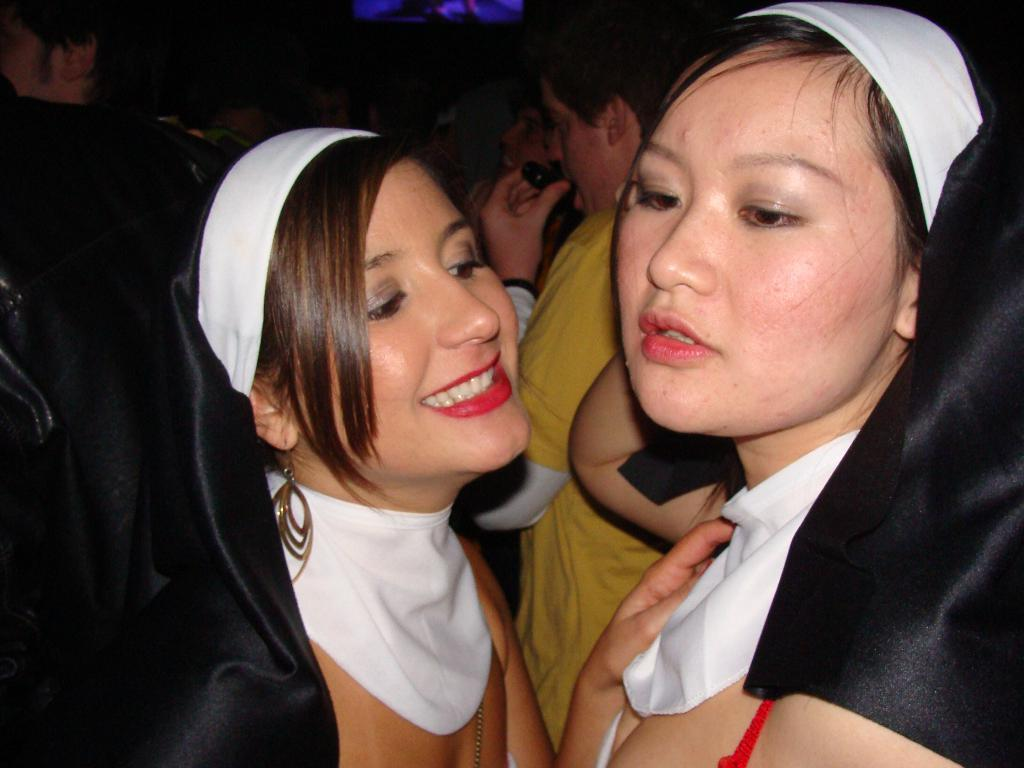What is happening in the image? There are people standing in the image. Can you describe the facial expression of the woman in the front? The woman in the front is smiling. What can be observed about the lighting in the image? The background of the image is dark. What type of substance is the woman holding in the image? There is no substance visible in the woman's hand in the image. Can you tell me how many bones are present in the image? There are no bones present in the image. 